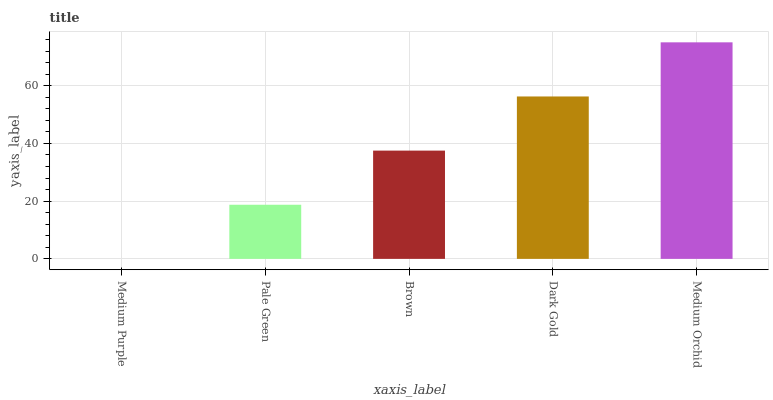Is Medium Purple the minimum?
Answer yes or no. Yes. Is Medium Orchid the maximum?
Answer yes or no. Yes. Is Pale Green the minimum?
Answer yes or no. No. Is Pale Green the maximum?
Answer yes or no. No. Is Pale Green greater than Medium Purple?
Answer yes or no. Yes. Is Medium Purple less than Pale Green?
Answer yes or no. Yes. Is Medium Purple greater than Pale Green?
Answer yes or no. No. Is Pale Green less than Medium Purple?
Answer yes or no. No. Is Brown the high median?
Answer yes or no. Yes. Is Brown the low median?
Answer yes or no. Yes. Is Medium Purple the high median?
Answer yes or no. No. Is Medium Orchid the low median?
Answer yes or no. No. 